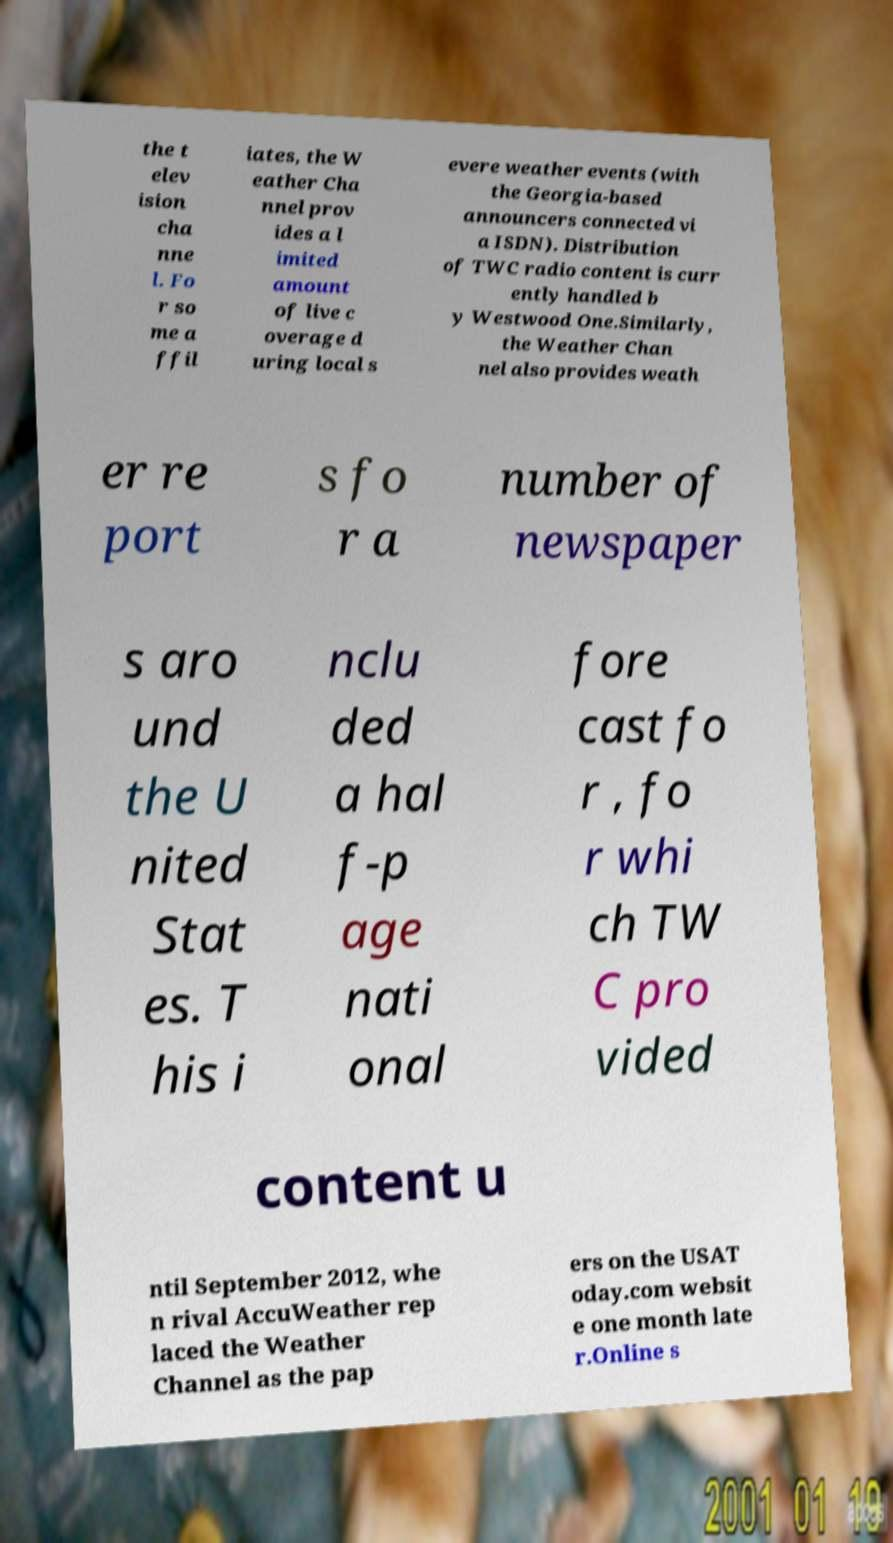Please identify and transcribe the text found in this image. the t elev ision cha nne l. Fo r so me a ffil iates, the W eather Cha nnel prov ides a l imited amount of live c overage d uring local s evere weather events (with the Georgia-based announcers connected vi a ISDN). Distribution of TWC radio content is curr ently handled b y Westwood One.Similarly, the Weather Chan nel also provides weath er re port s fo r a number of newspaper s aro und the U nited Stat es. T his i nclu ded a hal f-p age nati onal fore cast fo r , fo r whi ch TW C pro vided content u ntil September 2012, whe n rival AccuWeather rep laced the Weather Channel as the pap ers on the USAT oday.com websit e one month late r.Online s 